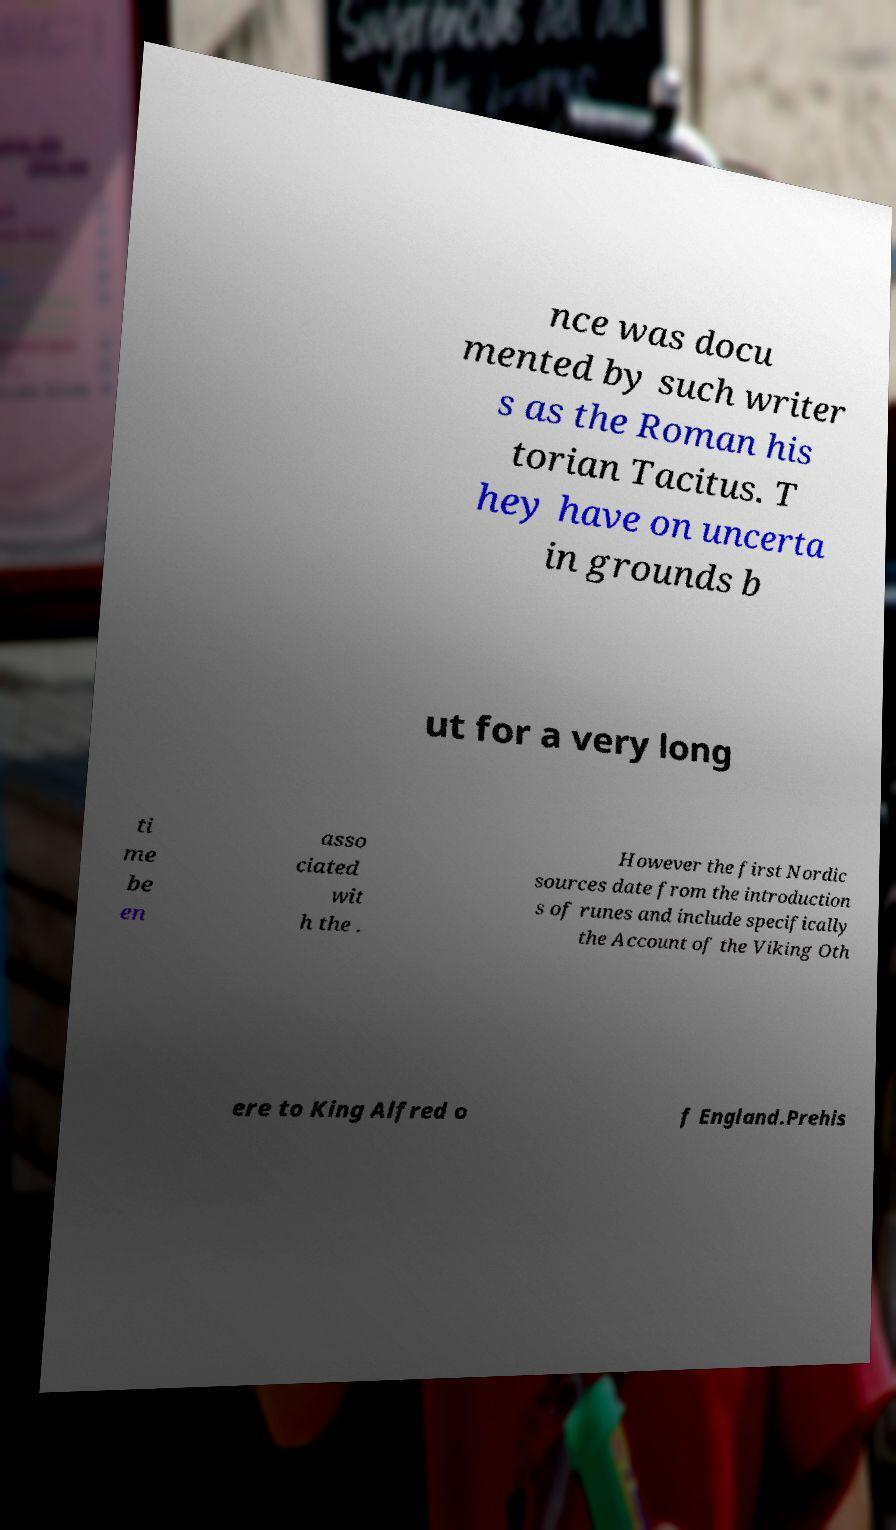Could you extract and type out the text from this image? nce was docu mented by such writer s as the Roman his torian Tacitus. T hey have on uncerta in grounds b ut for a very long ti me be en asso ciated wit h the . However the first Nordic sources date from the introduction s of runes and include specifically the Account of the Viking Oth ere to King Alfred o f England.Prehis 